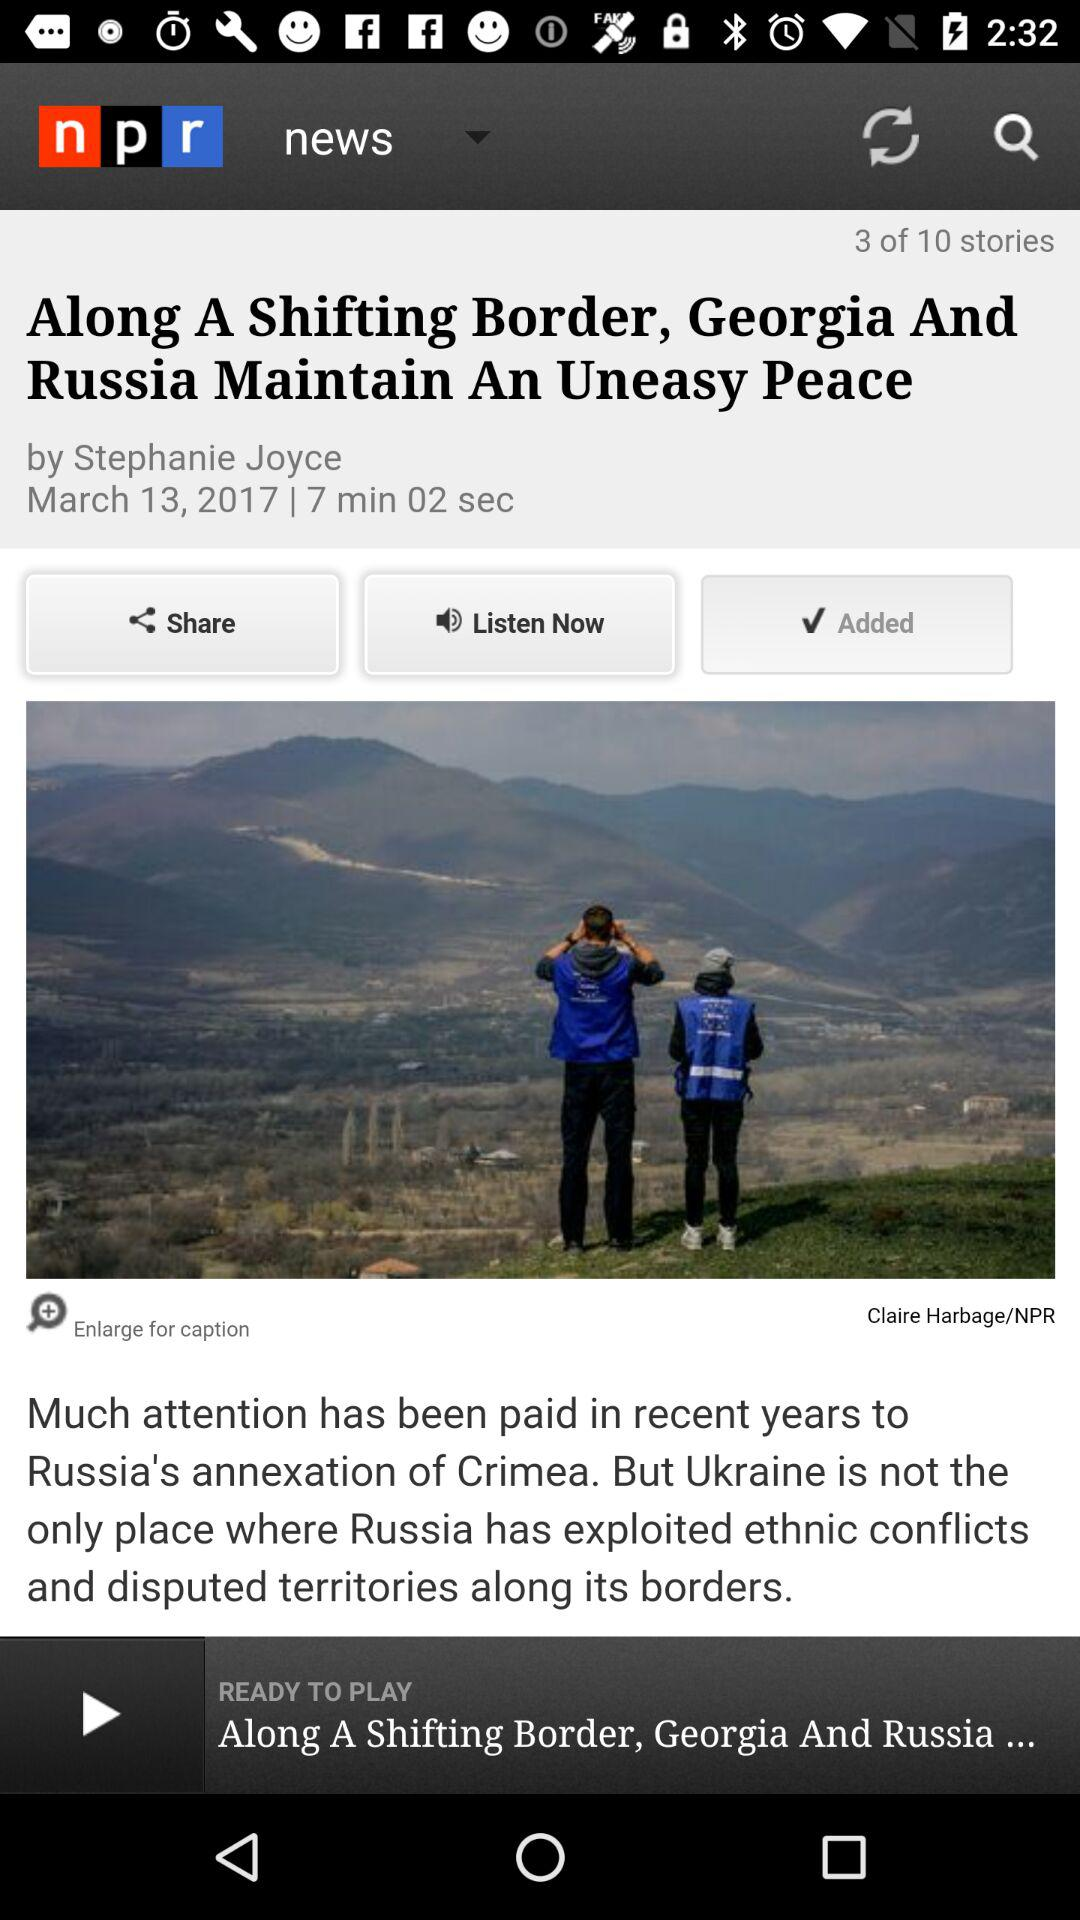When was the news about the leafy list of top cannabis locations published?
When the provided information is insufficient, respond with <no answer>. <no answer> 